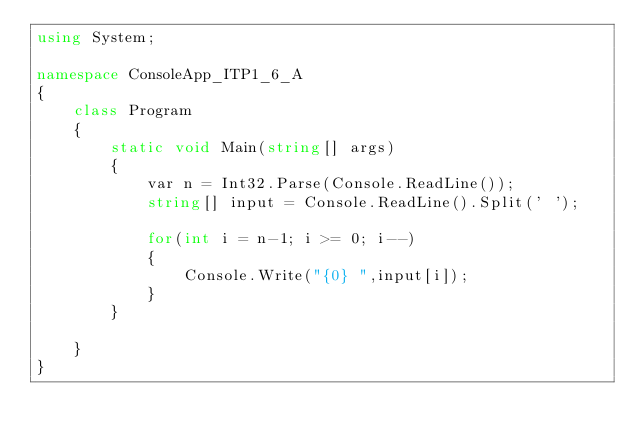Convert code to text. <code><loc_0><loc_0><loc_500><loc_500><_C#_>using System;

namespace ConsoleApp_ITP1_6_A
{
    class Program
    {
        static void Main(string[] args)
        {
            var n = Int32.Parse(Console.ReadLine());
            string[] input = Console.ReadLine().Split(' ');

            for(int i = n-1; i >= 0; i--)
            {
                Console.Write("{0} ",input[i]);
            }
        }

    }
}
</code> 